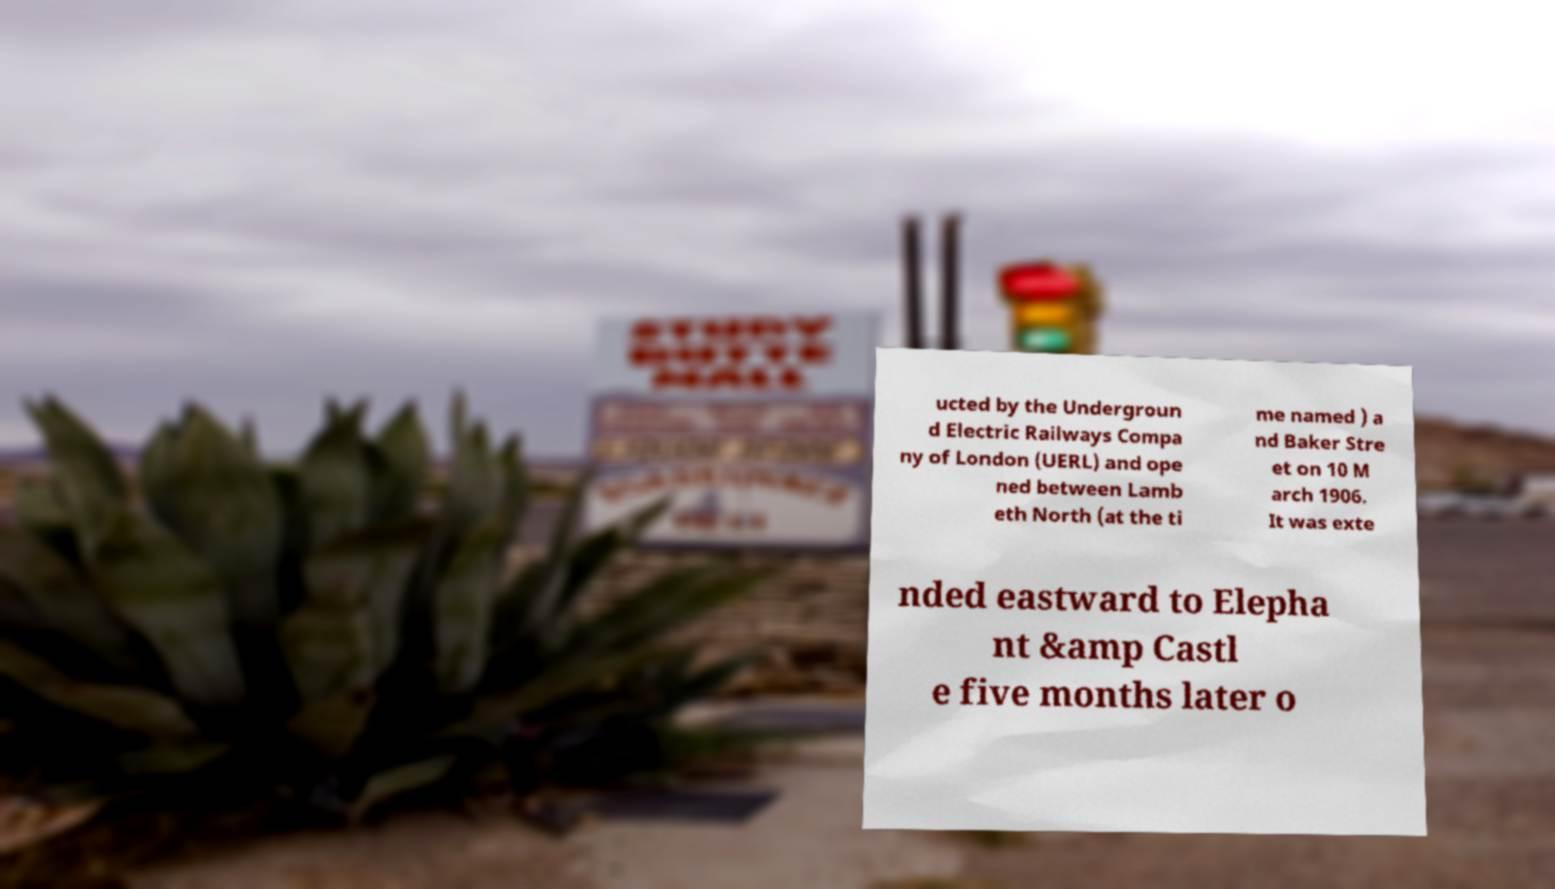Please identify and transcribe the text found in this image. ucted by the Undergroun d Electric Railways Compa ny of London (UERL) and ope ned between Lamb eth North (at the ti me named ) a nd Baker Stre et on 10 M arch 1906. It was exte nded eastward to Elepha nt &amp Castl e five months later o 